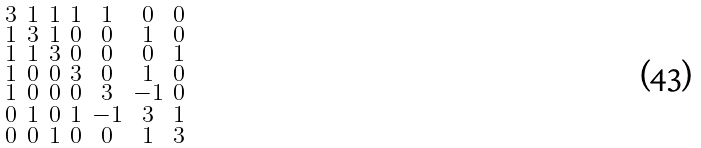Convert formula to latex. <formula><loc_0><loc_0><loc_500><loc_500>\begin{smallmatrix} 3 & 1 & 1 & 1 & 1 & 0 & 0 \\ 1 & 3 & 1 & 0 & 0 & 1 & 0 \\ 1 & 1 & 3 & 0 & 0 & 0 & 1 \\ 1 & 0 & 0 & 3 & 0 & 1 & 0 \\ 1 & 0 & 0 & 0 & 3 & - 1 & 0 \\ 0 & 1 & 0 & 1 & - 1 & 3 & 1 \\ 0 & 0 & 1 & 0 & 0 & 1 & 3 \end{smallmatrix}</formula> 